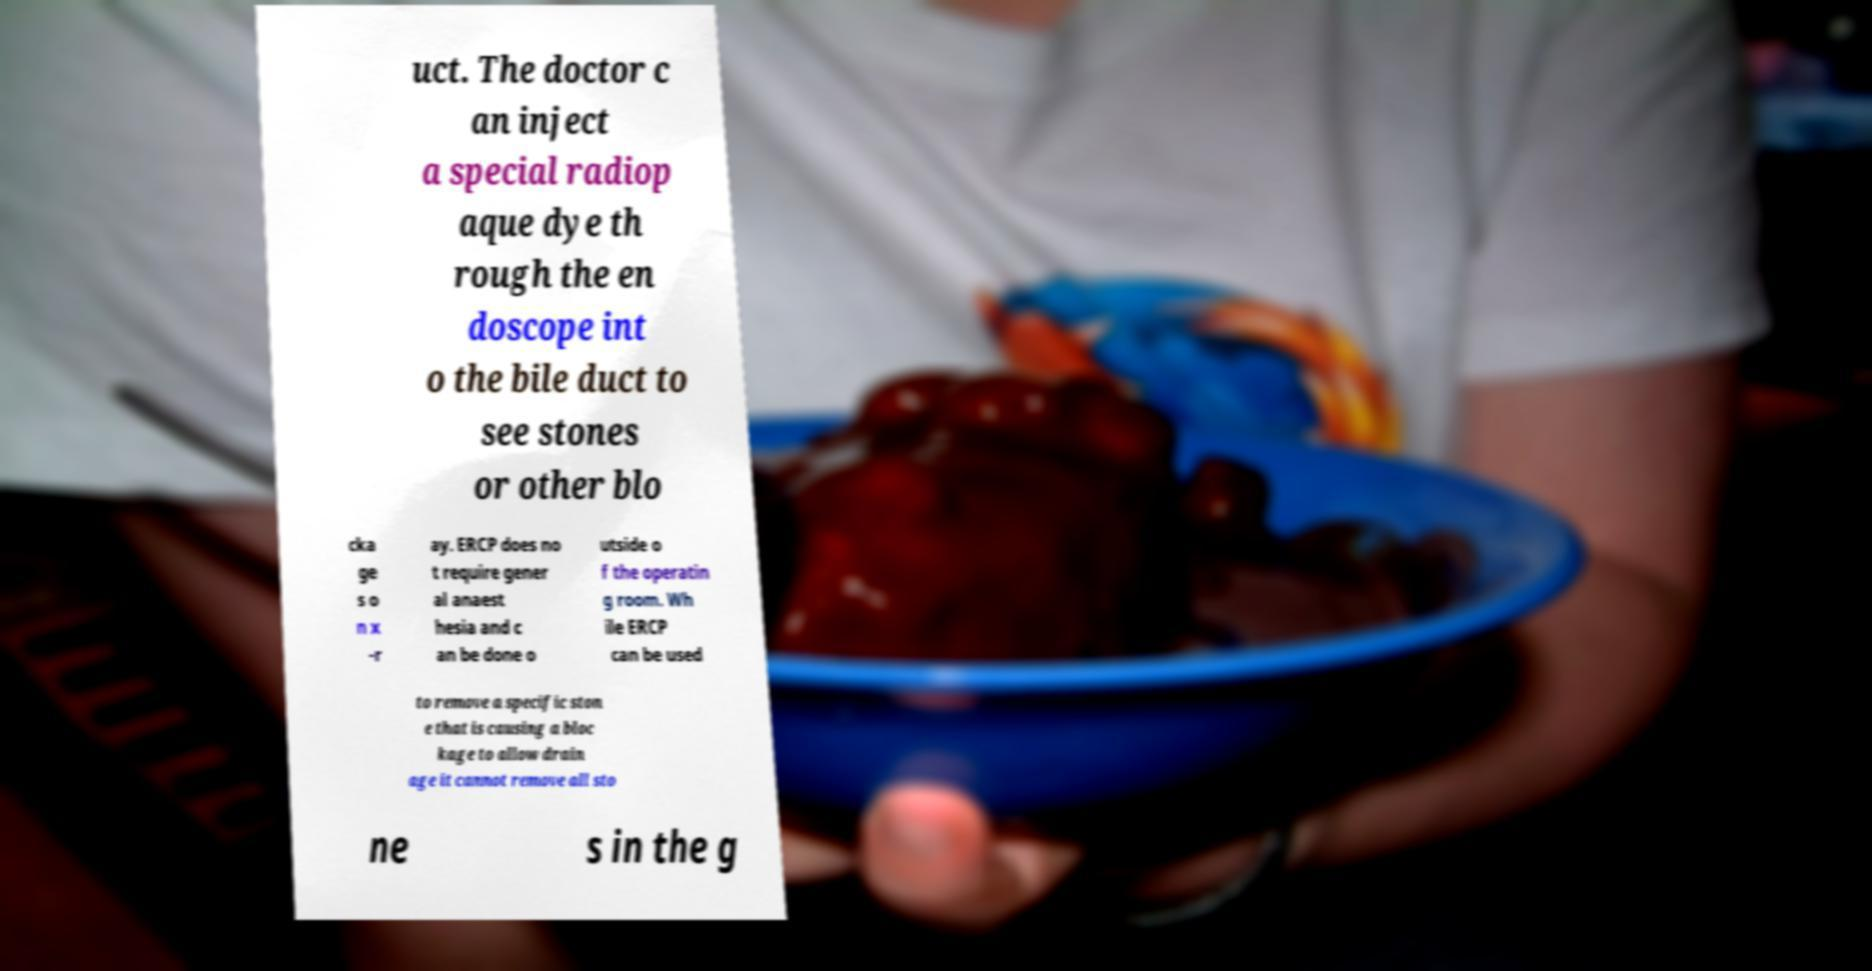Could you assist in decoding the text presented in this image and type it out clearly? uct. The doctor c an inject a special radiop aque dye th rough the en doscope int o the bile duct to see stones or other blo cka ge s o n x -r ay. ERCP does no t require gener al anaest hesia and c an be done o utside o f the operatin g room. Wh ile ERCP can be used to remove a specific ston e that is causing a bloc kage to allow drain age it cannot remove all sto ne s in the g 